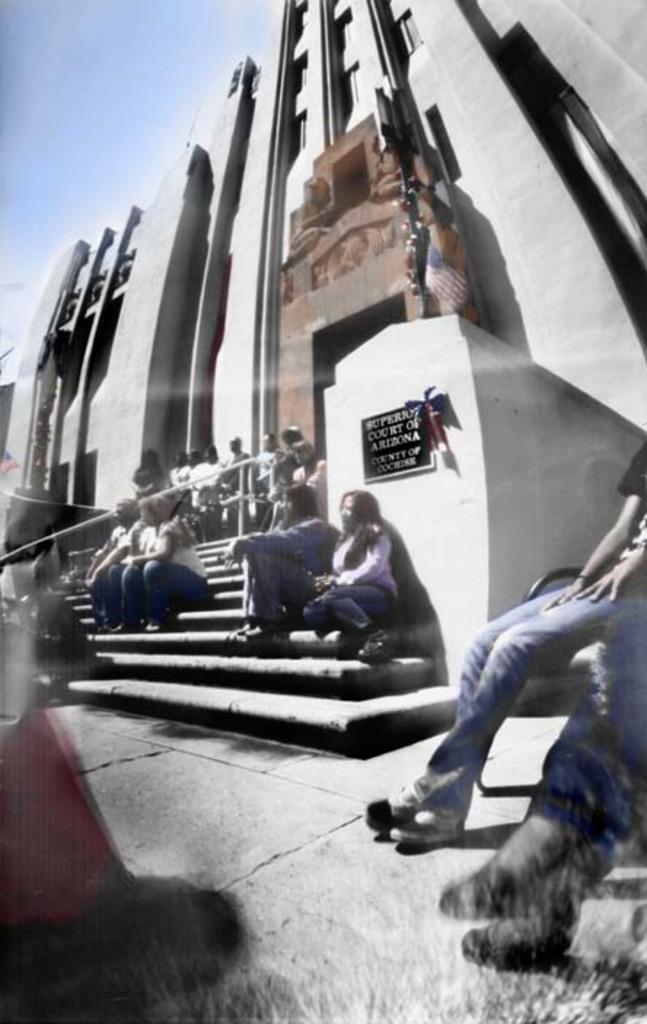Could you give a brief overview of what you see in this image? In the image we can see there are people sitting on the stairs and others are standing near the building. 